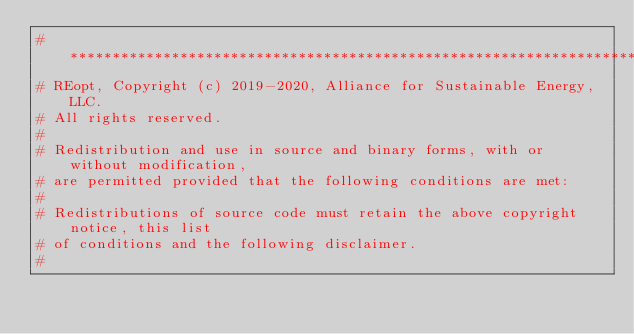Convert code to text. <code><loc_0><loc_0><loc_500><loc_500><_Python_># *********************************************************************************
# REopt, Copyright (c) 2019-2020, Alliance for Sustainable Energy, LLC.
# All rights reserved.
#
# Redistribution and use in source and binary forms, with or without modification,
# are permitted provided that the following conditions are met:
#
# Redistributions of source code must retain the above copyright notice, this list
# of conditions and the following disclaimer.
#</code> 